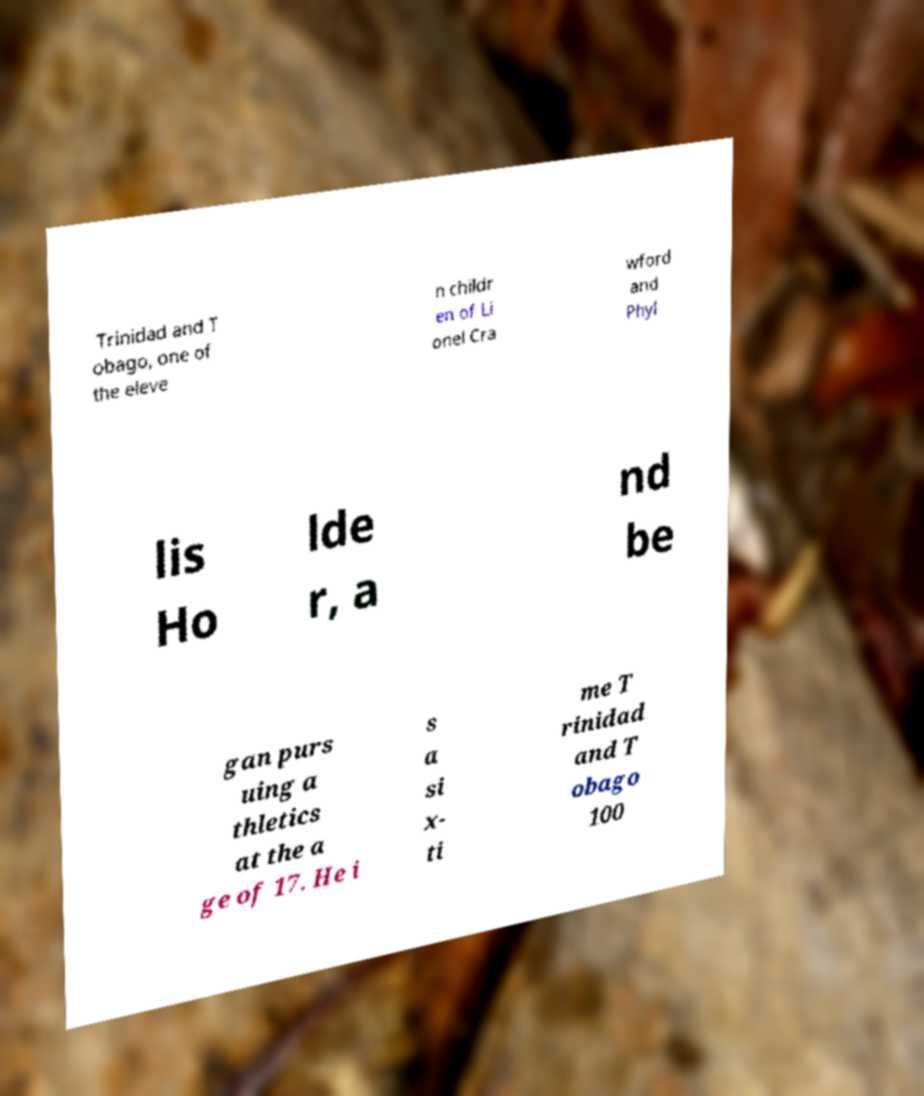For documentation purposes, I need the text within this image transcribed. Could you provide that? Trinidad and T obago, one of the eleve n childr en of Li onel Cra wford and Phyl lis Ho lde r, a nd be gan purs uing a thletics at the a ge of 17. He i s a si x- ti me T rinidad and T obago 100 